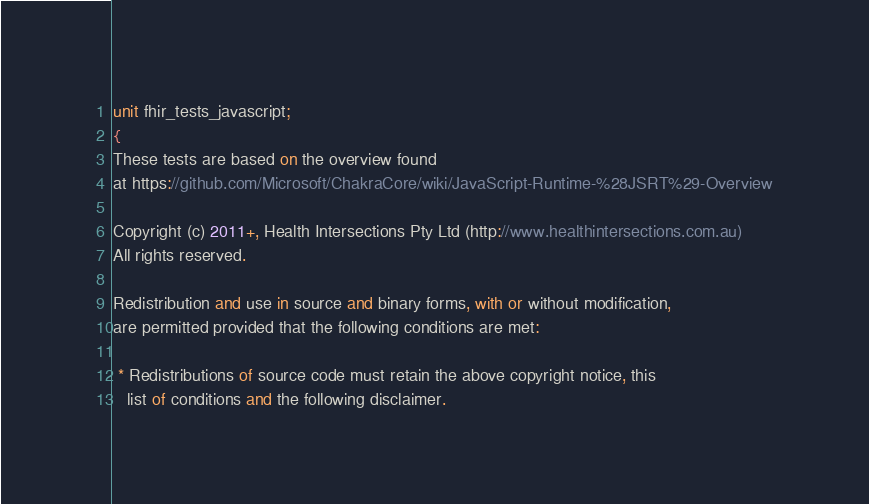<code> <loc_0><loc_0><loc_500><loc_500><_Pascal_>unit fhir_tests_javascript;
{
These tests are based on the overview found
at https://github.com/Microsoft/ChakraCore/wiki/JavaScript-Runtime-%28JSRT%29-Overview

Copyright (c) 2011+, Health Intersections Pty Ltd (http://www.healthintersections.com.au)
All rights reserved.

Redistribution and use in source and binary forms, with or without modification,
are permitted provided that the following conditions are met:

 * Redistributions of source code must retain the above copyright notice, this
   list of conditions and the following disclaimer.</code> 